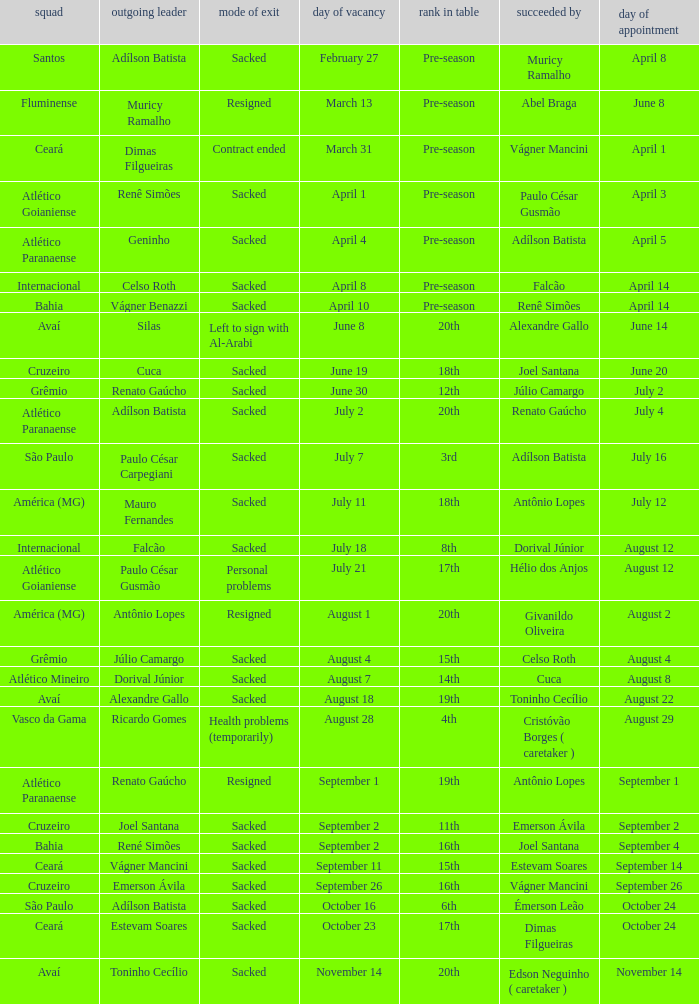What team hired Renato Gaúcho? Atlético Paranaense. 